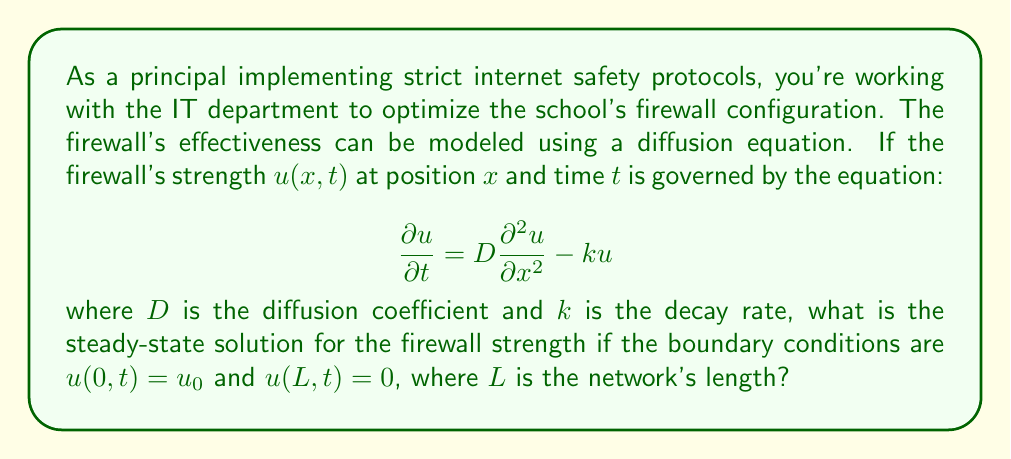Can you answer this question? To solve this problem, we need to follow these steps:

1) For the steady-state solution, $\frac{\partial u}{\partial t} = 0$. This reduces our equation to:

   $$D\frac{d^2 u}{dx^2} - ku = 0$$

2) This is a second-order linear differential equation. The general solution has the form:

   $$u(x) = Ae^{\lambda x} + Be^{-\lambda x}$$

   where $\lambda = \sqrt{\frac{k}{D}}$

3) Now we apply the boundary conditions:
   
   At $x = 0$: $u(0) = u_0 = A + B$
   At $x = L$: $u(L) = 0 = Ae^{\lambda L} + Be^{-\lambda L}$

4) From these conditions, we can solve for A and B:

   $$A = \frac{u_0}{1 - e^{-2\lambda L}}e^{-\lambda L}$$
   $$B = \frac{u_0}{1 - e^{-2\lambda L}}e^{\lambda L}$$

5) Substituting these back into our general solution:

   $$u(x) = \frac{u_0}{1 - e^{-2\lambda L}}(e^{-\lambda L}e^{\lambda x} + e^{\lambda L}e^{-\lambda x})$$

6) This can be simplified to:

   $$u(x) = u_0\frac{\sinh(\lambda(L-x))}{\sinh(\lambda L)}$$

This is the steady-state solution for the firewall strength.
Answer: $$u(x) = u_0\frac{\sinh(\lambda(L-x))}{\sinh(\lambda L)}$$
where $\lambda = \sqrt{\frac{k}{D}}$ 